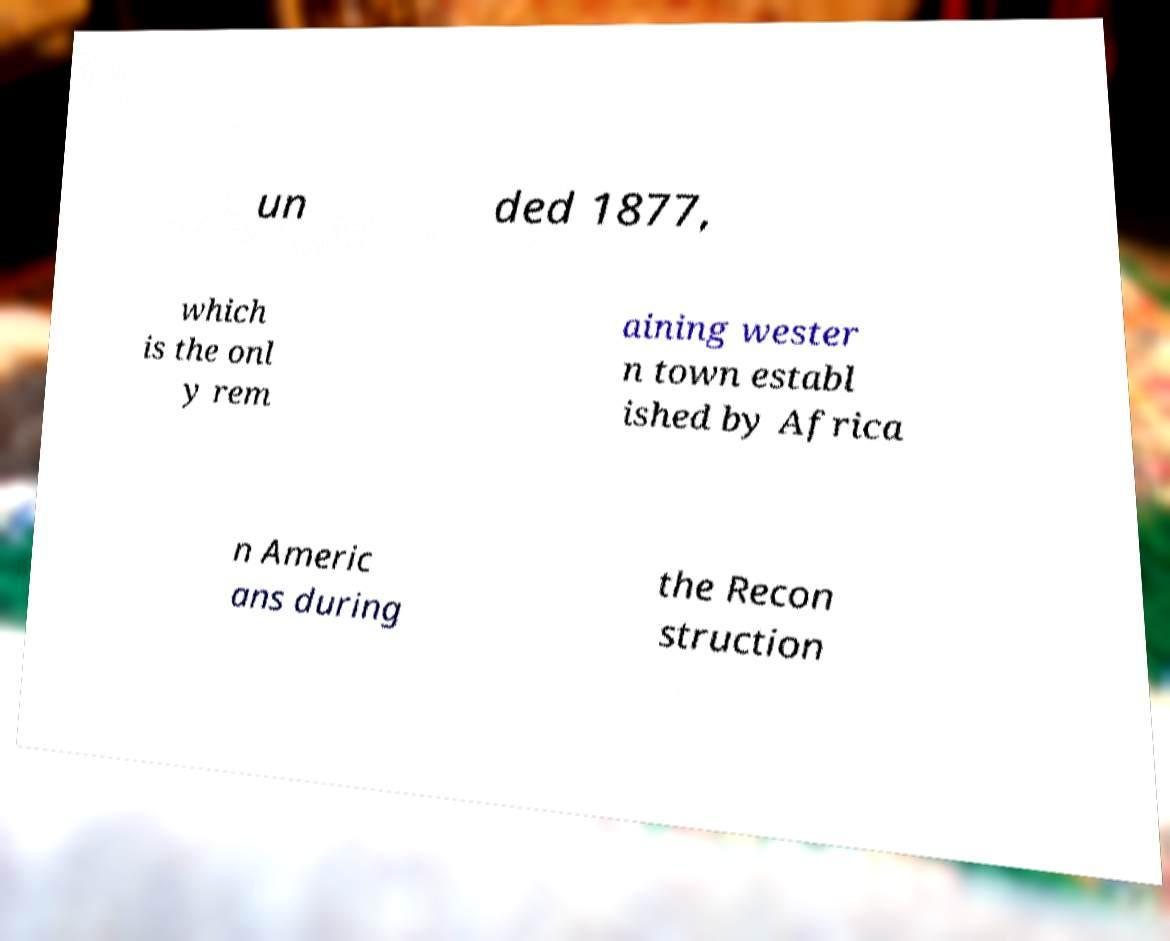There's text embedded in this image that I need extracted. Can you transcribe it verbatim? un ded 1877, which is the onl y rem aining wester n town establ ished by Africa n Americ ans during the Recon struction 